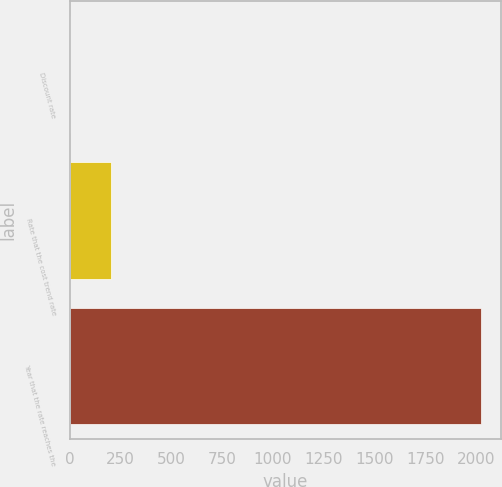<chart> <loc_0><loc_0><loc_500><loc_500><bar_chart><fcel>Discount rate<fcel>Rate that the cost trend rate<fcel>Year that the rate reaches the<nl><fcel>3.5<fcel>205.35<fcel>2022<nl></chart> 